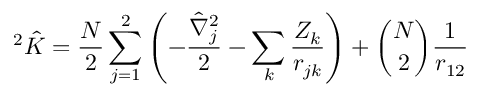Convert formula to latex. <formula><loc_0><loc_0><loc_500><loc_500>^ { 2 } { \hat { K } } = \frac { N } { 2 } \sum _ { j = 1 } ^ { 2 } { \left ( - \frac { { \hat { \nabla } } _ { j } ^ { 2 } } { 2 } - \sum _ { k } { \frac { Z _ { k } } { r _ { j k } } } \right ) } + \binom { N } { 2 } \frac { 1 } { r _ { 1 2 } }</formula> 